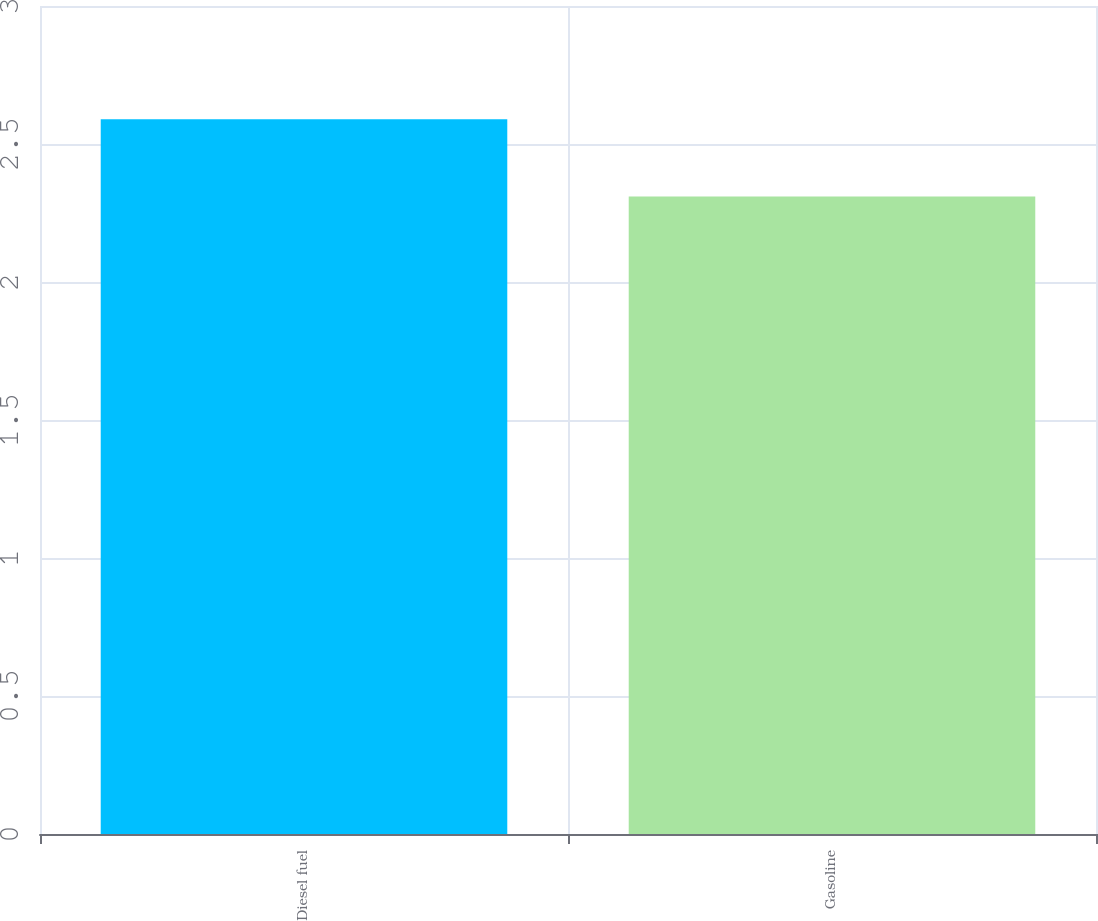Convert chart to OTSL. <chart><loc_0><loc_0><loc_500><loc_500><bar_chart><fcel>Diesel fuel<fcel>Gasoline<nl><fcel>2.59<fcel>2.31<nl></chart> 